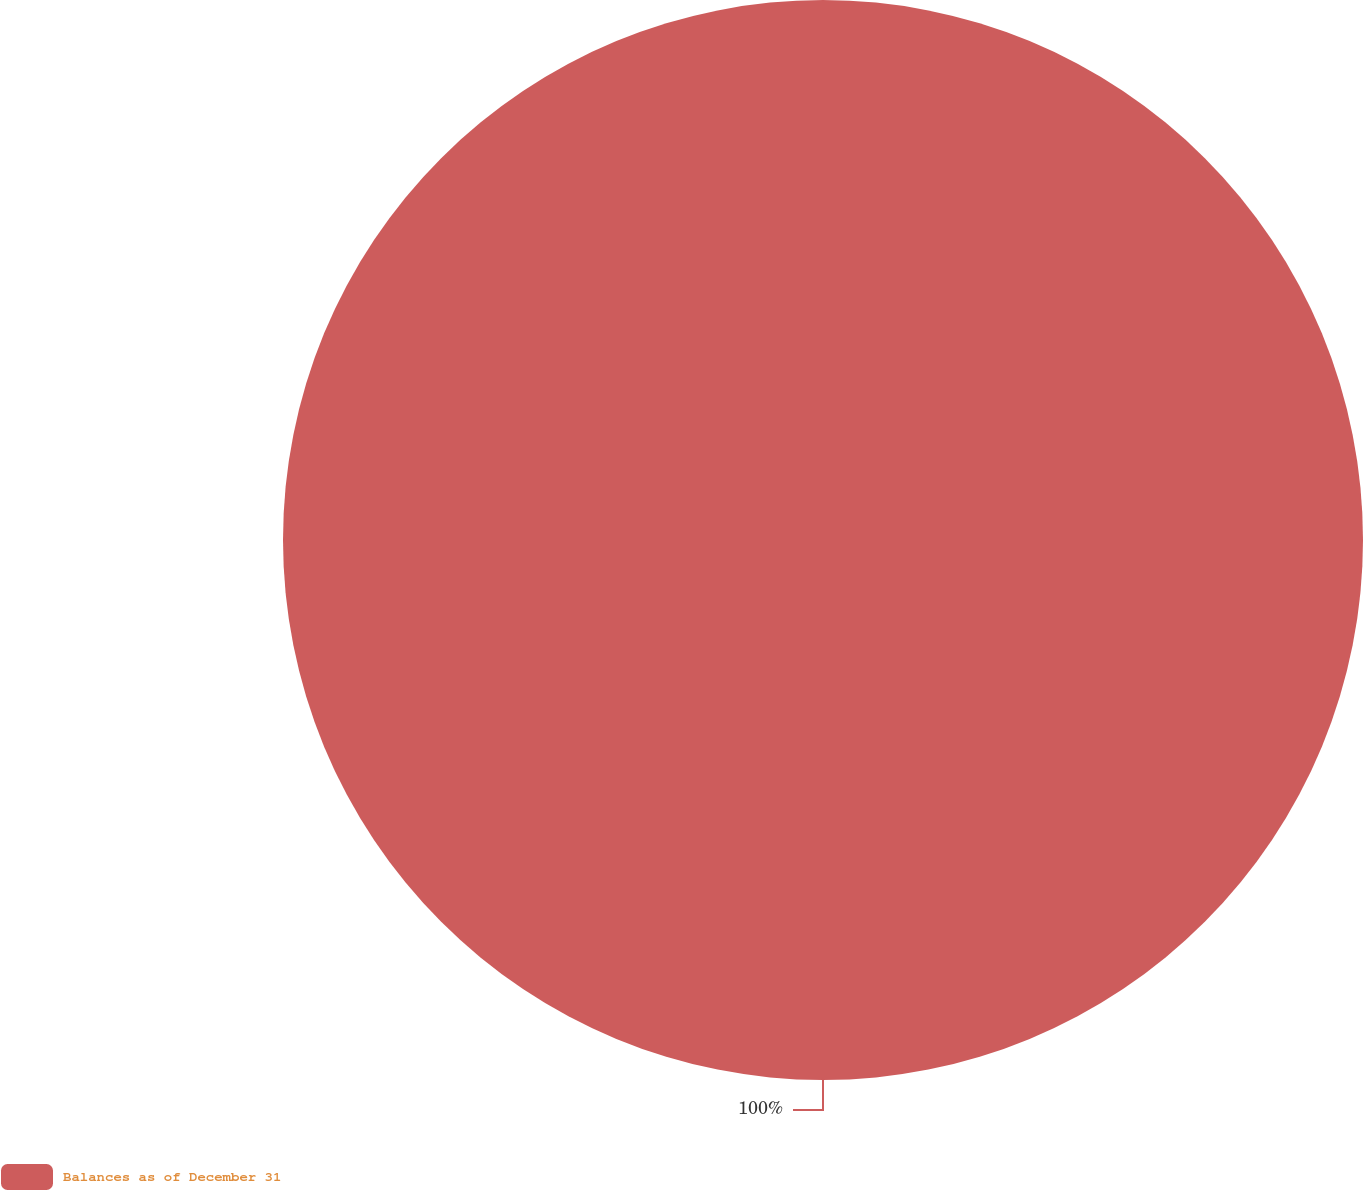<chart> <loc_0><loc_0><loc_500><loc_500><pie_chart><fcel>Balances as of December 31<nl><fcel>100.0%<nl></chart> 